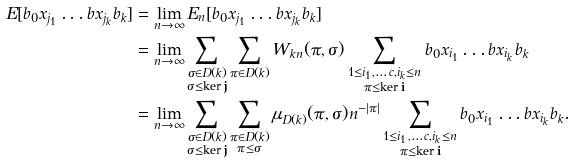Convert formula to latex. <formula><loc_0><loc_0><loc_500><loc_500>E [ b _ { 0 } x _ { j _ { 1 } } \dots b x _ { j _ { k } } b _ { k } ] & = \lim _ { n \to \infty } E _ { n } [ b _ { 0 } x _ { j _ { 1 } } \dots b x _ { j _ { k } } b _ { k } ] \\ & = \lim _ { n \to \infty } \sum _ { \substack { \sigma \in D ( k ) \\ \sigma \leq \ker \mathbf j } } \sum _ { \pi \in D ( k ) } W _ { k n } ( \pi , \sigma ) \sum _ { \substack { 1 \leq i _ { 1 } , \dots c , i _ { k } \leq n \\ \pi \leq \ker \mathbf i } } b _ { 0 } x _ { i _ { 1 } } \dots b x _ { i _ { k } } b _ { k } \\ & = \lim _ { n \to \infty } \sum _ { \substack { \sigma \in D ( k ) \\ \sigma \leq \ker \mathbf j } } \sum _ { \substack { \pi \in D ( k ) \\ \pi \leq \sigma } } \mu _ { D ( k ) } ( \pi , \sigma ) n ^ { - | \pi | } \sum _ { \substack { 1 \leq i _ { 1 } , \dots c , i _ { k } \leq n \\ \pi \leq \ker \mathbf i } } b _ { 0 } x _ { i _ { 1 } } \dots b x _ { i _ { k } } b _ { k } .</formula> 